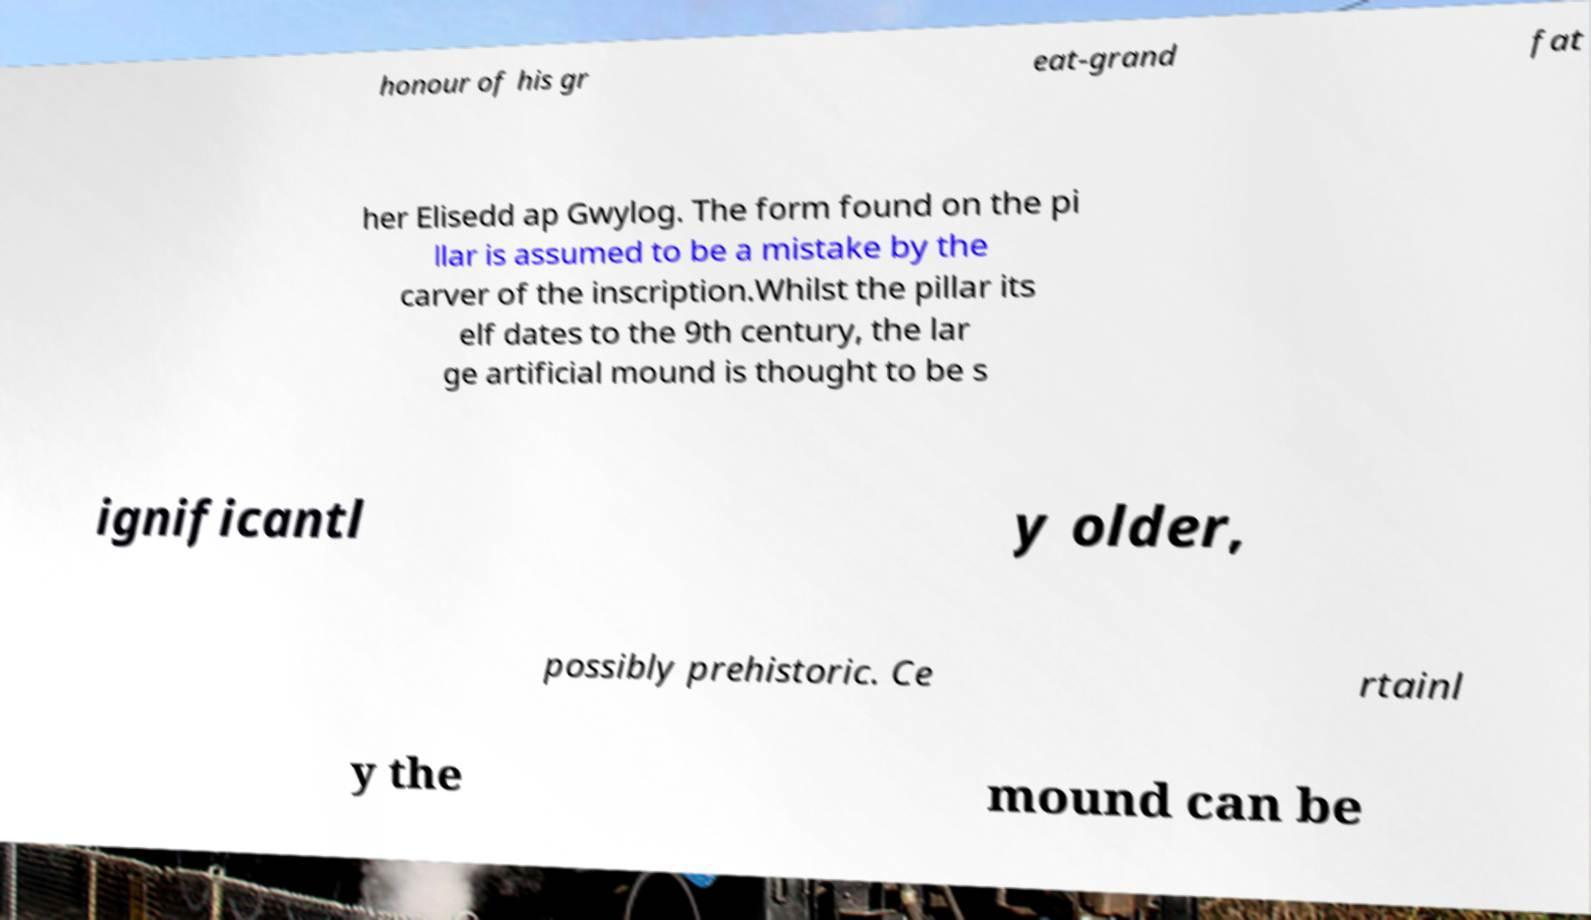Can you accurately transcribe the text from the provided image for me? honour of his gr eat-grand fat her Elisedd ap Gwylog. The form found on the pi llar is assumed to be a mistake by the carver of the inscription.Whilst the pillar its elf dates to the 9th century, the lar ge artificial mound is thought to be s ignificantl y older, possibly prehistoric. Ce rtainl y the mound can be 